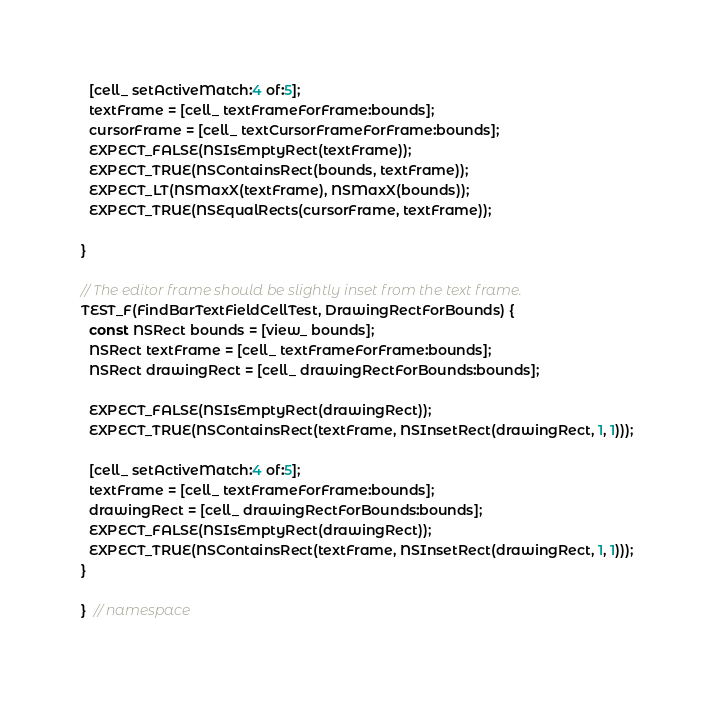<code> <loc_0><loc_0><loc_500><loc_500><_ObjectiveC_>  [cell_ setActiveMatch:4 of:5];
  textFrame = [cell_ textFrameForFrame:bounds];
  cursorFrame = [cell_ textCursorFrameForFrame:bounds];
  EXPECT_FALSE(NSIsEmptyRect(textFrame));
  EXPECT_TRUE(NSContainsRect(bounds, textFrame));
  EXPECT_LT(NSMaxX(textFrame), NSMaxX(bounds));
  EXPECT_TRUE(NSEqualRects(cursorFrame, textFrame));

}

// The editor frame should be slightly inset from the text frame.
TEST_F(FindBarTextFieldCellTest, DrawingRectForBounds) {
  const NSRect bounds = [view_ bounds];
  NSRect textFrame = [cell_ textFrameForFrame:bounds];
  NSRect drawingRect = [cell_ drawingRectForBounds:bounds];

  EXPECT_FALSE(NSIsEmptyRect(drawingRect));
  EXPECT_TRUE(NSContainsRect(textFrame, NSInsetRect(drawingRect, 1, 1)));

  [cell_ setActiveMatch:4 of:5];
  textFrame = [cell_ textFrameForFrame:bounds];
  drawingRect = [cell_ drawingRectForBounds:bounds];
  EXPECT_FALSE(NSIsEmptyRect(drawingRect));
  EXPECT_TRUE(NSContainsRect(textFrame, NSInsetRect(drawingRect, 1, 1)));
}

}  // namespace
</code> 